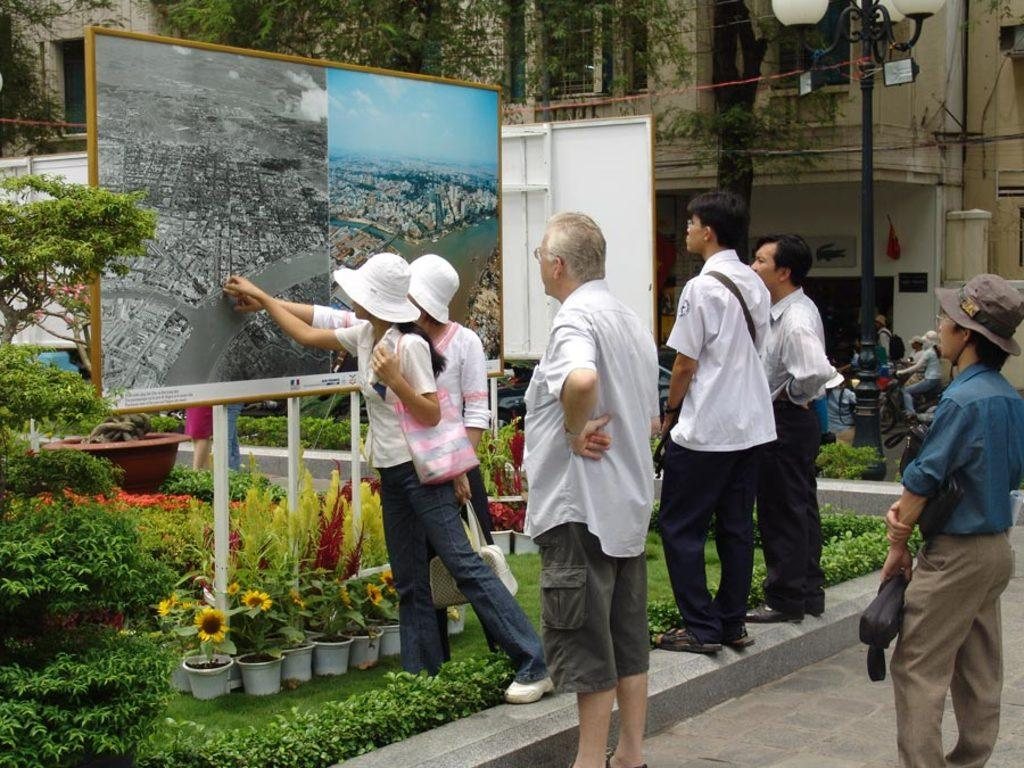How many people are in the image? There are people in the image, but the exact number is not specified. What type of plants are in the image? There are plants in the image, but the specific type is not mentioned. What are the pots used for in the image? The pots are likely used for holding the plants, but their exact purpose is not stated. What color or type of flowers are in the image? There are flowers in the image, but their color or type is not specified. What is the texture or color of the grass in the image? The grass is present in the image, but its texture or color is not described. What is the purpose of the lights in the image? The lights are in the image, but their purpose is not mentioned. What are the boards used for in the image? The boards are in the image, but their purpose or function is not stated. What are the poles used for in the image? The poles are in the image, but their purpose or function is not mentioned. What can be seen in the background of the image? There is a building and trees in the background of the image. What type of coach is driving the people in the image? There is no coach or vehicle present in the image; it features people, plants, pots, flowers, grass, lights, boards, poles, a building, and trees. What type of wine is being served at the event in the image? There is no mention of an event or wine in the image. What tools does the carpenter use in the image? There is no carpenter or tools present in the image. 